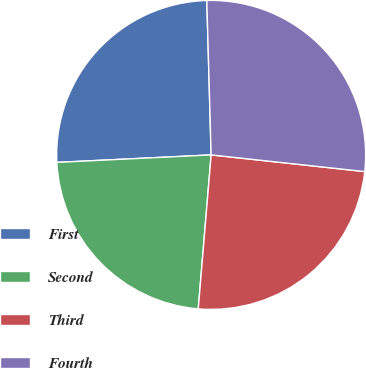Convert chart. <chart><loc_0><loc_0><loc_500><loc_500><pie_chart><fcel>First<fcel>Second<fcel>Third<fcel>Fourth<nl><fcel>25.33%<fcel>22.9%<fcel>24.61%<fcel>27.17%<nl></chart> 